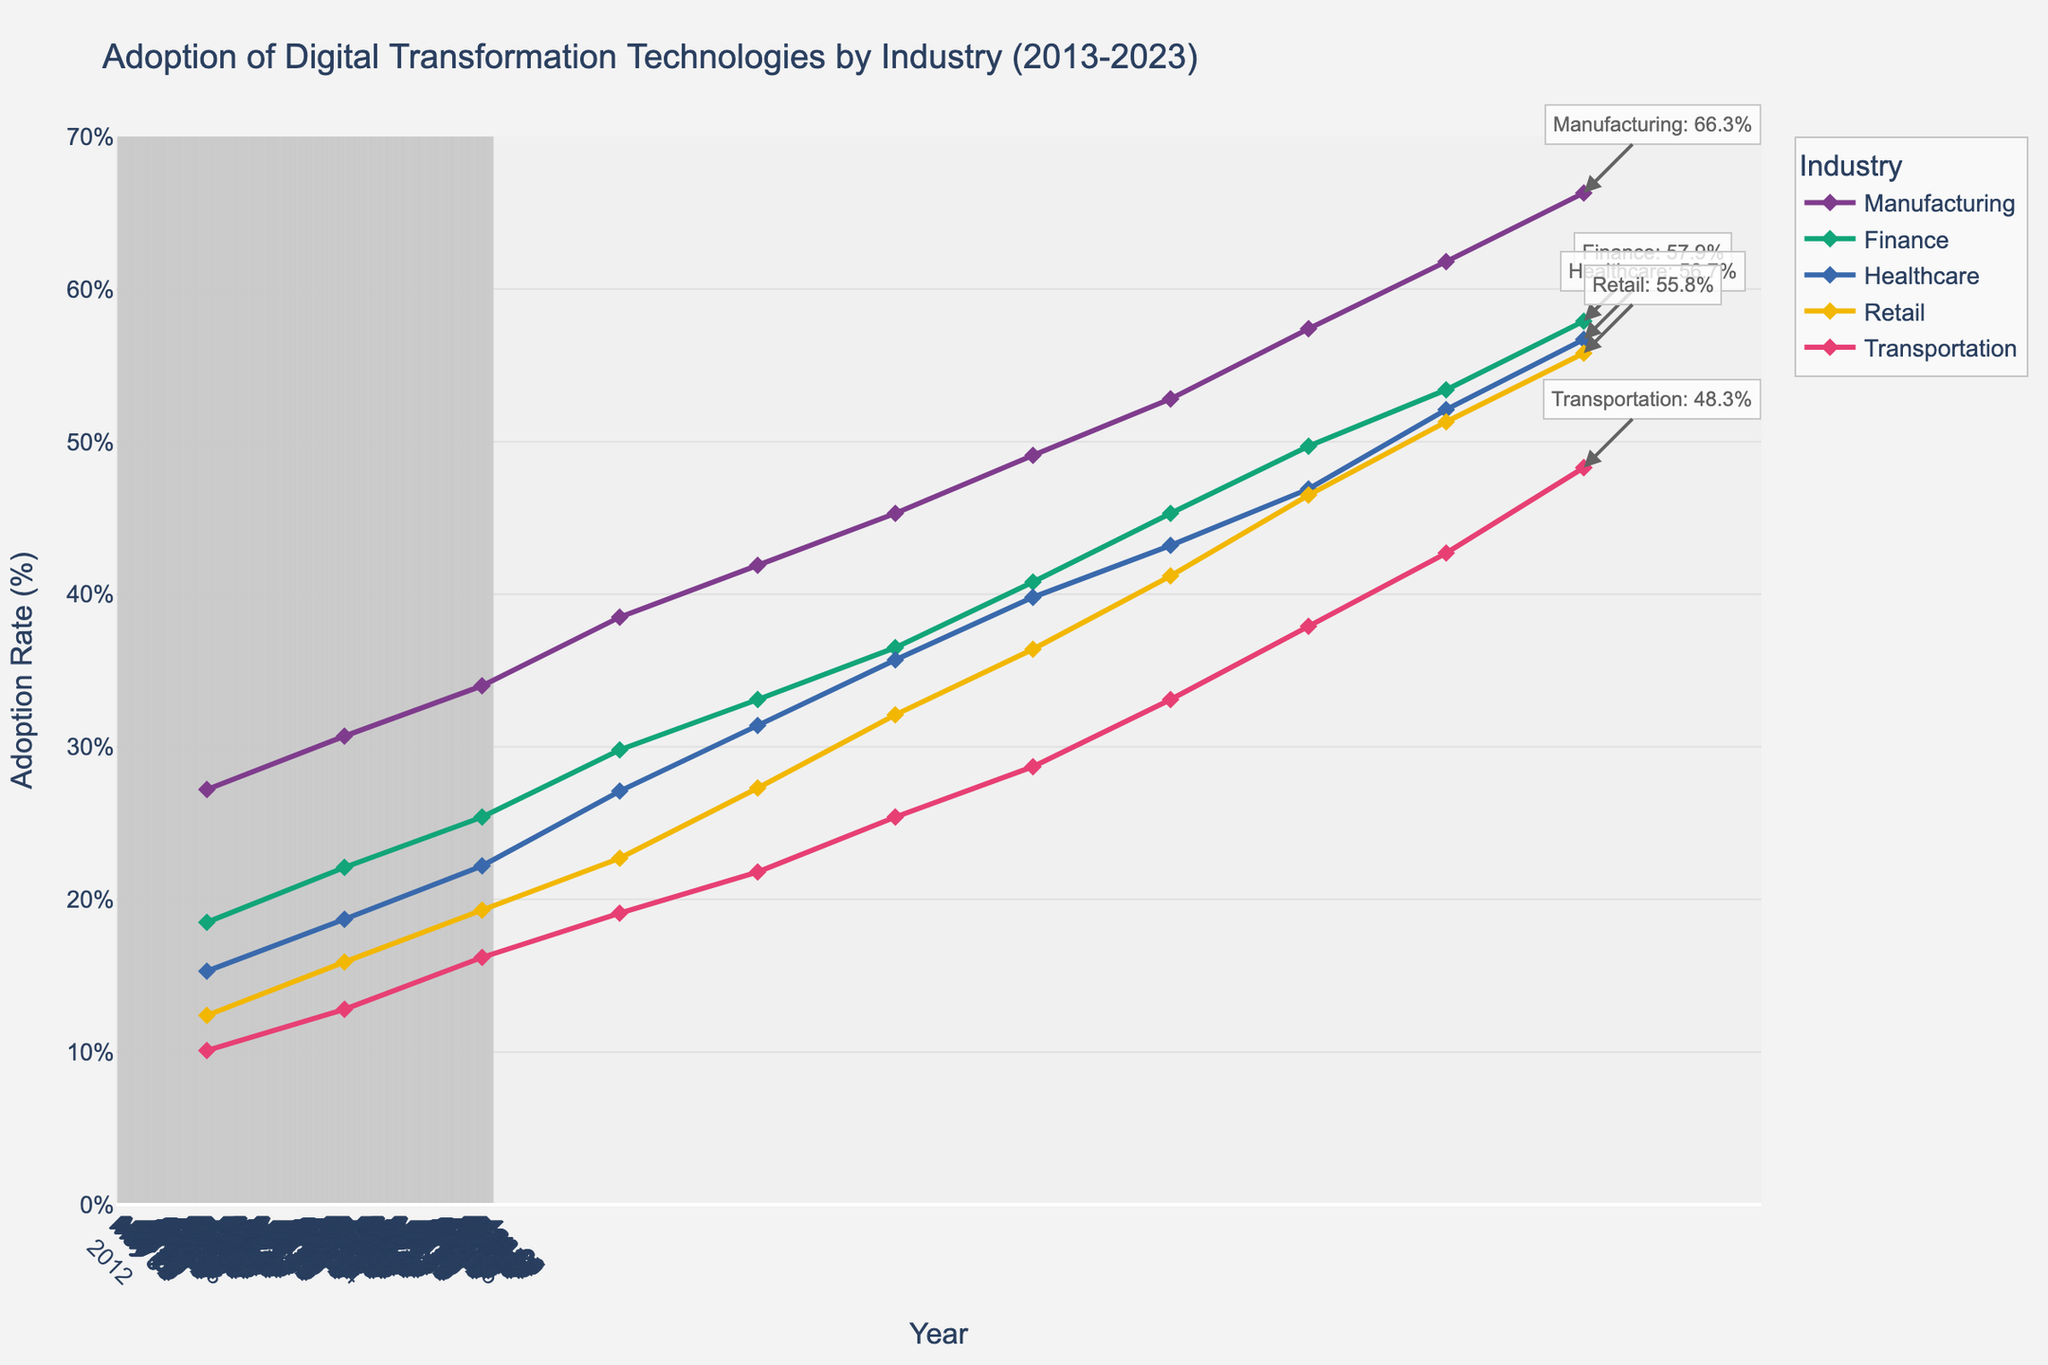What is the adoption rate of digital transformation technologies in the healthcare industry in 2023? In the figure, locate the year 2023 on the x-axis, then find the corresponding point for the healthcare industry by looking for the label. The adoption rate indicated for healthcare in 2023 is 56.7%.
Answer: 56.7% Which industry had the lowest adoption rate in 2013? In the figure, locate the year 2013 on the x-axis. Then, look at the adoption rates for all industries in that year. Transportation has the lowest adoption rate of 10.1%.
Answer: Transportation How has the adoption rate in the retail industry changed from 2013 to 2023? In the figure, locate the points for the retail industry in the years 2013 and 2023. The adoption rate in 2013 was 12.4%, and in 2023 it increased to 55.8%. Calculate the difference: 55.8% - 12.4% = 43.4%.
Answer: Increased by 43.4% Which industry has shown the most consistent yearly increase in adoption rate? Examine the slope of the lines for each industry over the timeline. The manufacturing industry has the most consistently increasing slope without large fluctuations, indicating a steady annual increase.
Answer: Manufacturing What is the average adoption rate of digital transformation technologies across all industries in 2023? Locate the adoption rates for each industry in 2023: Manufacturing (66.3%), Finance (57.9%), Healthcare (56.7%), Retail (55.8%), Transportation (48.3%). Calculate the average: (66.3 + 57.9 + 56.7 + 55.8 + 48.3) / 5 = 57.0%.
Answer: 57.0% Between which consecutive years did the finance industry see the largest increase in adoption rate? Analyze the vertical distance between consecutive points for the finance industry. The largest increase occurs between 2019 (40.8%) and 2020 (45.3%), which is an increase of 4.5%.
Answer: 2019 to 2020 Which year did the healthcare industry surpass a 50% adoption rate? Locate the point at which the healthcare industry's adoption rate crosses the 50% threshold. This occurs in the year 2022.
Answer: 2022 How much higher is the adoption rate in the manufacturing industry compared to transportation in 2020? Locate the points for manufacturing and transportation for the year 2020. The adoption rate for manufacturing is 52.8%, and for transportation, it is 33.1%. Calculate the difference: 52.8% - 33.1% = 19.7%.
Answer: 19.7% What trend can be observed for all industries' adoption rates from 2013 to 2023? Observe the overall direction of the lines for all industries. Each industry shows an upward trend over the period from 2013 to 2023, indicating increasing adoption rates over time.
Answer: Increasing Which industry had the largest adoption rate increase between 2016 and 2017? Compare the vertical distance between the points of each industry between 2016 and 2017. Manufacturing shows the largest increase, going from 38.5% to 41.9%, giving a difference of 3.4%.
Answer: Manufacturing 